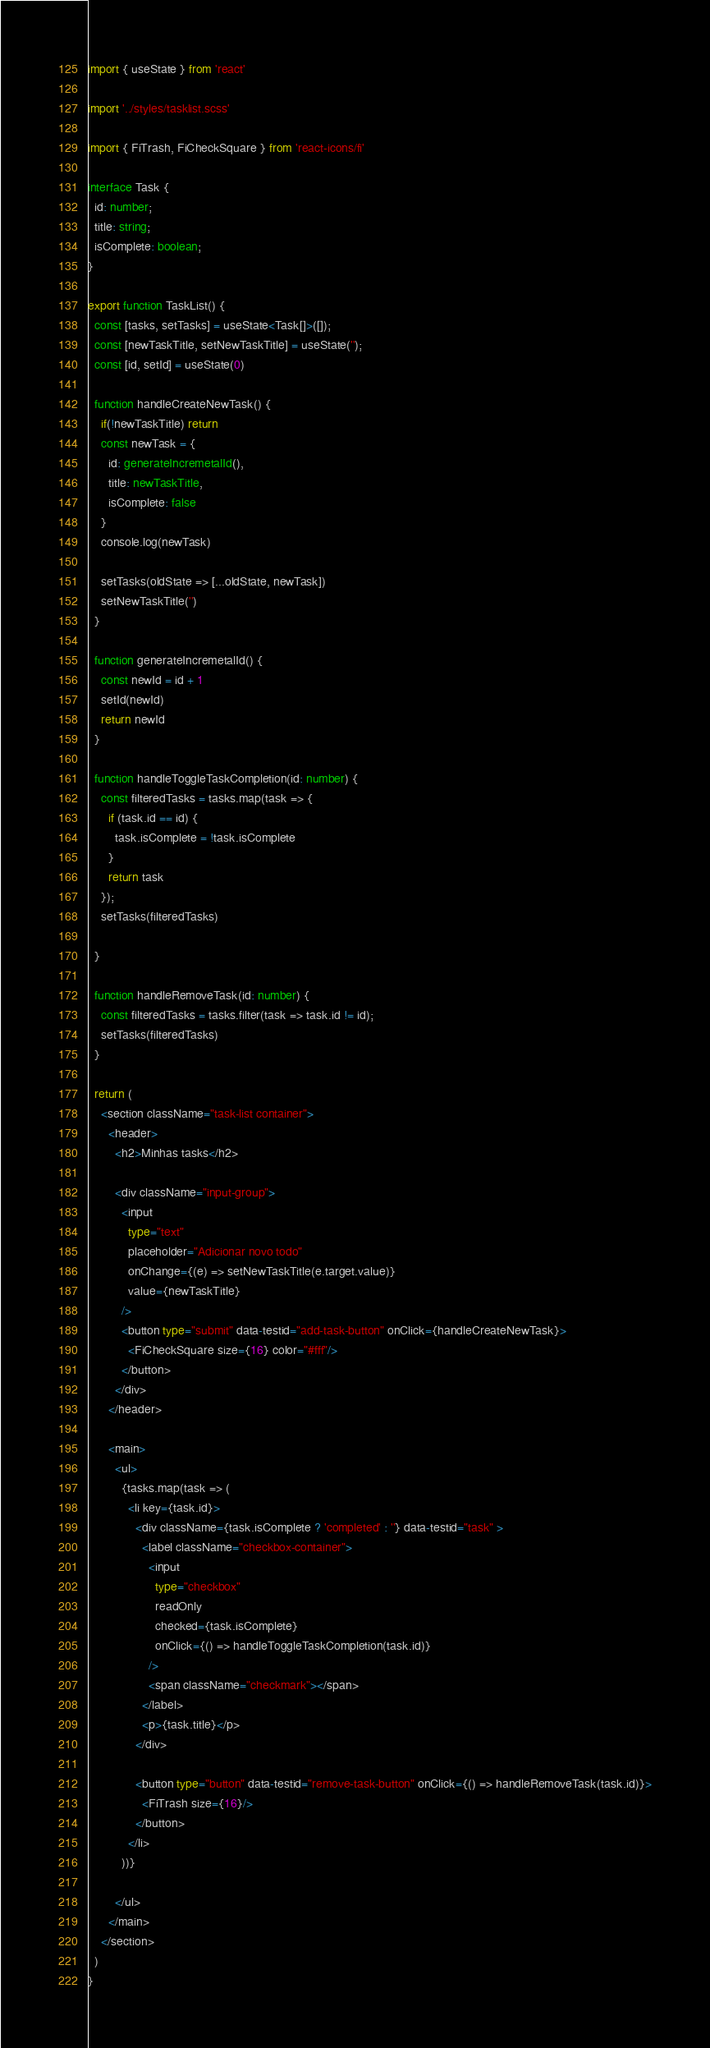<code> <loc_0><loc_0><loc_500><loc_500><_TypeScript_>import { useState } from 'react'

import '../styles/tasklist.scss'

import { FiTrash, FiCheckSquare } from 'react-icons/fi'

interface Task {
  id: number;
  title: string;
  isComplete: boolean;
}

export function TaskList() {
  const [tasks, setTasks] = useState<Task[]>([]);
  const [newTaskTitle, setNewTaskTitle] = useState('');
  const [id, setId] = useState(0)

  function handleCreateNewTask() {
    if(!newTaskTitle) return
    const newTask = {
      id: generateIncremetalId(),
      title: newTaskTitle,
      isComplete: false
    }
    console.log(newTask)

    setTasks(oldState => [...oldState, newTask])
    setNewTaskTitle('')
  }

  function generateIncremetalId() {
    const newId = id + 1
    setId(newId)
    return newId
  }

  function handleToggleTaskCompletion(id: number) {
    const filteredTasks = tasks.map(task => {
      if (task.id == id) {
        task.isComplete = !task.isComplete 
      }
      return task
    });
    setTasks(filteredTasks)
   
  }

  function handleRemoveTask(id: number) {
    const filteredTasks = tasks.filter(task => task.id != id);
    setTasks(filteredTasks)
  }

  return (
    <section className="task-list container">
      <header>
        <h2>Minhas tasks</h2>

        <div className="input-group">
          <input 
            type="text" 
            placeholder="Adicionar novo todo" 
            onChange={(e) => setNewTaskTitle(e.target.value)}
            value={newTaskTitle}
          />
          <button type="submit" data-testid="add-task-button" onClick={handleCreateNewTask}>
            <FiCheckSquare size={16} color="#fff"/>
          </button>
        </div>
      </header>

      <main>
        <ul>
          {tasks.map(task => (
            <li key={task.id}>
              <div className={task.isComplete ? 'completed' : ''} data-testid="task" >
                <label className="checkbox-container">
                  <input 
                    type="checkbox"
                    readOnly
                    checked={task.isComplete}
                    onClick={() => handleToggleTaskCompletion(task.id)}
                  />
                  <span className="checkmark"></span>
                </label>
                <p>{task.title}</p>
              </div>

              <button type="button" data-testid="remove-task-button" onClick={() => handleRemoveTask(task.id)}>
                <FiTrash size={16}/>
              </button>
            </li>
          ))}
          
        </ul>
      </main>
    </section>
  )
}</code> 